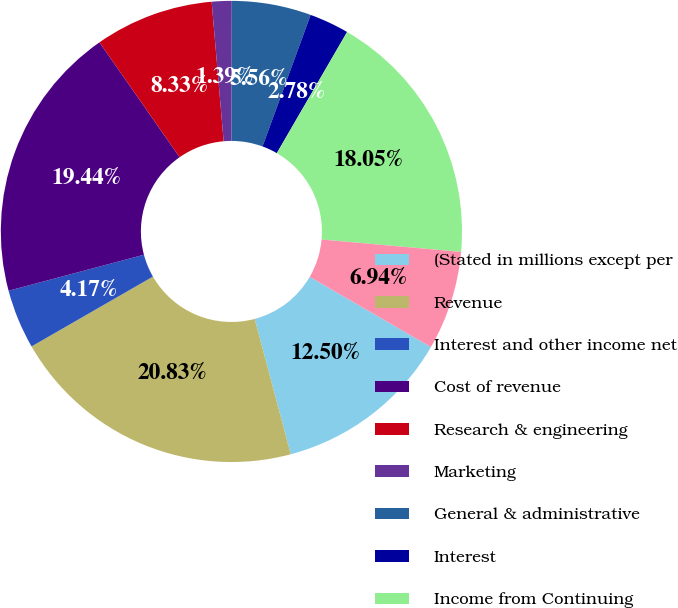Convert chart. <chart><loc_0><loc_0><loc_500><loc_500><pie_chart><fcel>(Stated in millions except per<fcel>Revenue<fcel>Interest and other income net<fcel>Cost of revenue<fcel>Research & engineering<fcel>Marketing<fcel>General & administrative<fcel>Interest<fcel>Income from Continuing<fcel>Taxes on income<nl><fcel>12.5%<fcel>20.83%<fcel>4.17%<fcel>19.44%<fcel>8.33%<fcel>1.39%<fcel>5.56%<fcel>2.78%<fcel>18.05%<fcel>6.94%<nl></chart> 